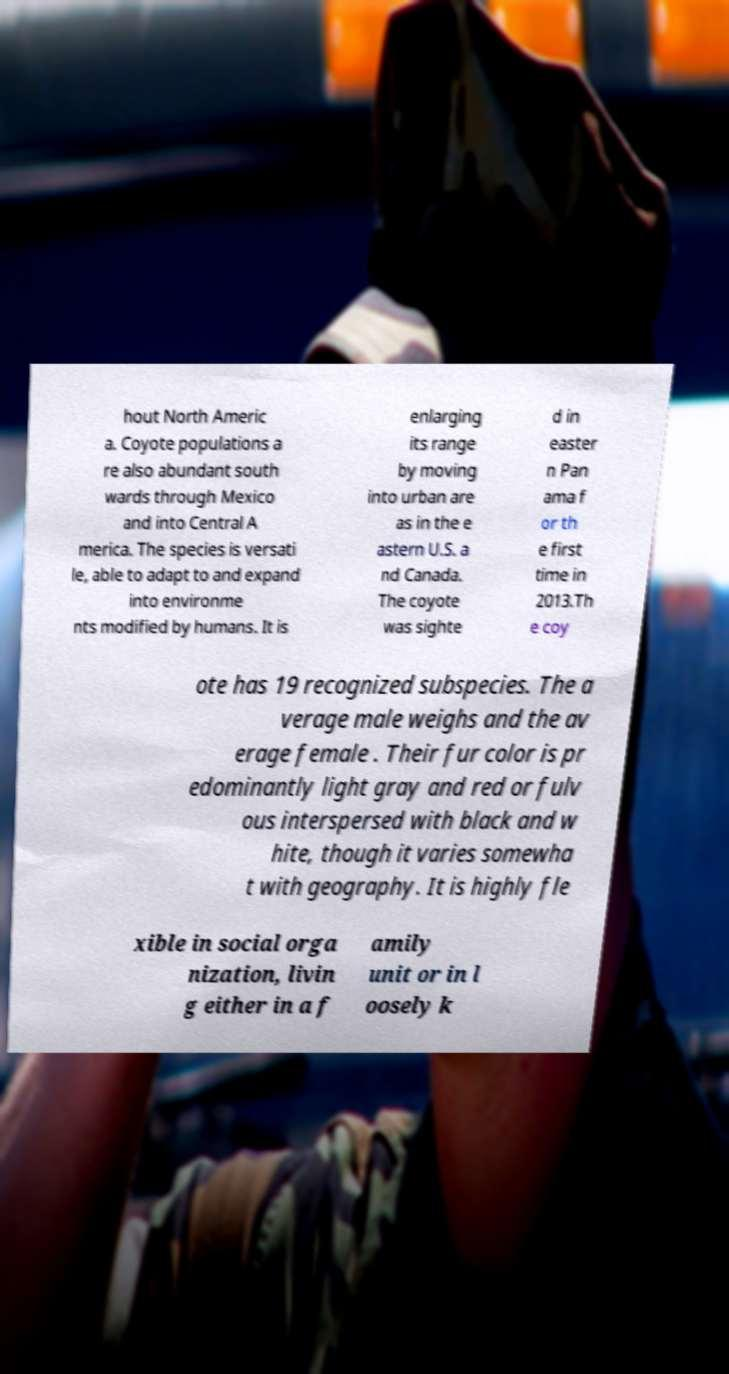For documentation purposes, I need the text within this image transcribed. Could you provide that? hout North Americ a. Coyote populations a re also abundant south wards through Mexico and into Central A merica. The species is versati le, able to adapt to and expand into environme nts modified by humans. It is enlarging its range by moving into urban are as in the e astern U.S. a nd Canada. The coyote was sighte d in easter n Pan ama f or th e first time in 2013.Th e coy ote has 19 recognized subspecies. The a verage male weighs and the av erage female . Their fur color is pr edominantly light gray and red or fulv ous interspersed with black and w hite, though it varies somewha t with geography. It is highly fle xible in social orga nization, livin g either in a f amily unit or in l oosely k 